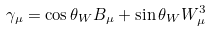Convert formula to latex. <formula><loc_0><loc_0><loc_500><loc_500>\gamma _ { \mu } = \cos { \theta _ { W } } B _ { \mu } + \sin { \theta _ { W } } W _ { \mu } ^ { 3 }</formula> 